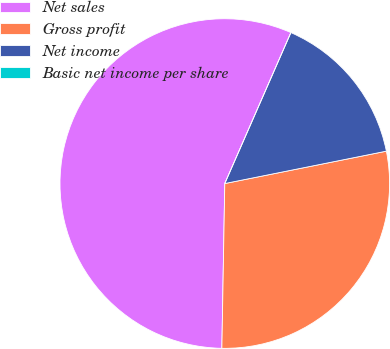Convert chart to OTSL. <chart><loc_0><loc_0><loc_500><loc_500><pie_chart><fcel>Net sales<fcel>Gross profit<fcel>Net income<fcel>Basic net income per share<nl><fcel>56.29%<fcel>28.43%<fcel>15.28%<fcel>0.0%<nl></chart> 